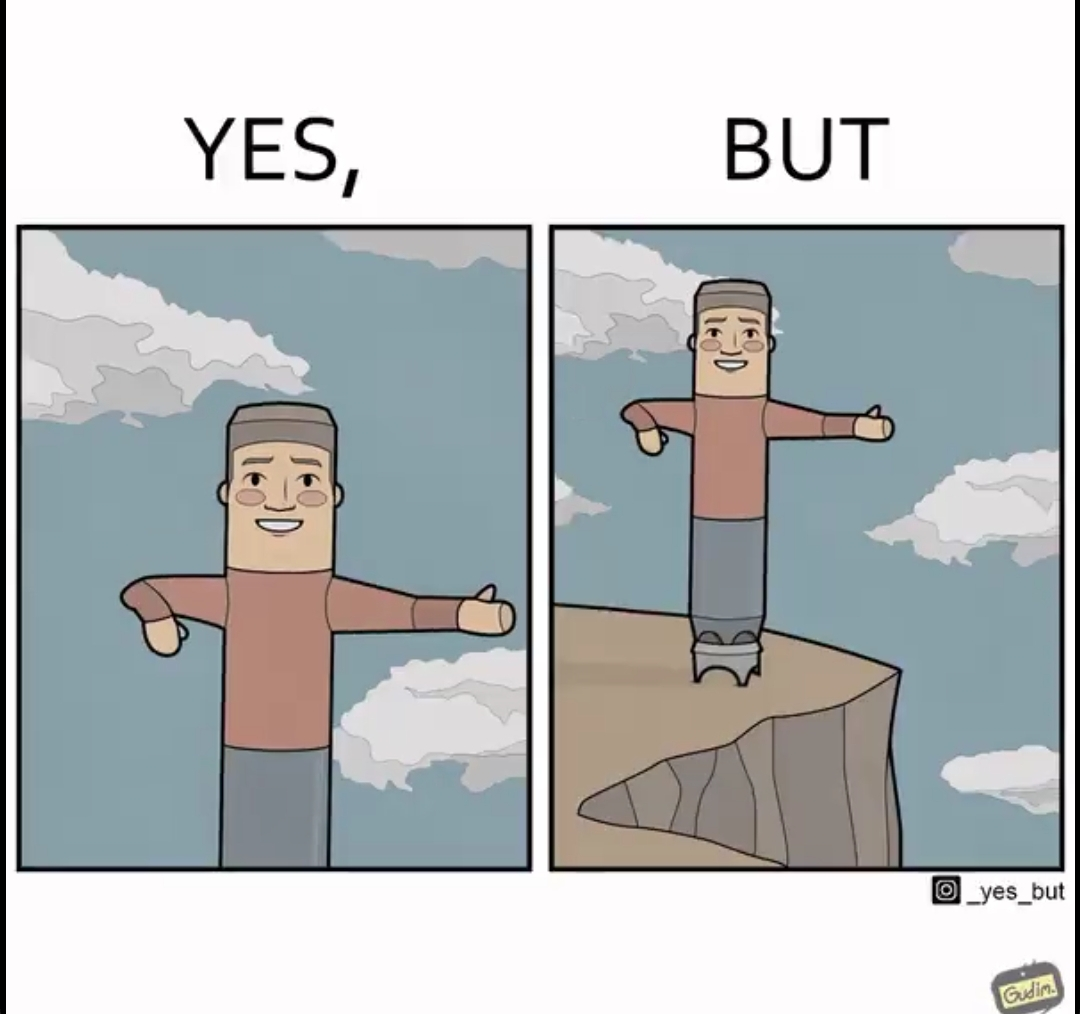What is the satirical meaning behind this image? The image is ironic, because in the first image a statue is shown with smiling face pointing in some direction but in the second image the same statue is seen as pointing at the wrong path which can cause accidents that too with the smiling face 